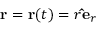<formula> <loc_0><loc_0><loc_500><loc_500>r = r ( t ) = r \hat { e } _ { r }</formula> 